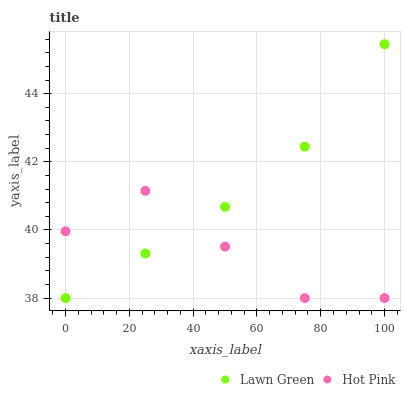Does Hot Pink have the minimum area under the curve?
Answer yes or no. Yes. Does Lawn Green have the maximum area under the curve?
Answer yes or no. Yes. Does Hot Pink have the maximum area under the curve?
Answer yes or no. No. Is Lawn Green the smoothest?
Answer yes or no. Yes. Is Hot Pink the roughest?
Answer yes or no. Yes. Is Hot Pink the smoothest?
Answer yes or no. No. Does Lawn Green have the lowest value?
Answer yes or no. Yes. Does Lawn Green have the highest value?
Answer yes or no. Yes. Does Hot Pink have the highest value?
Answer yes or no. No. Does Lawn Green intersect Hot Pink?
Answer yes or no. Yes. Is Lawn Green less than Hot Pink?
Answer yes or no. No. Is Lawn Green greater than Hot Pink?
Answer yes or no. No. 